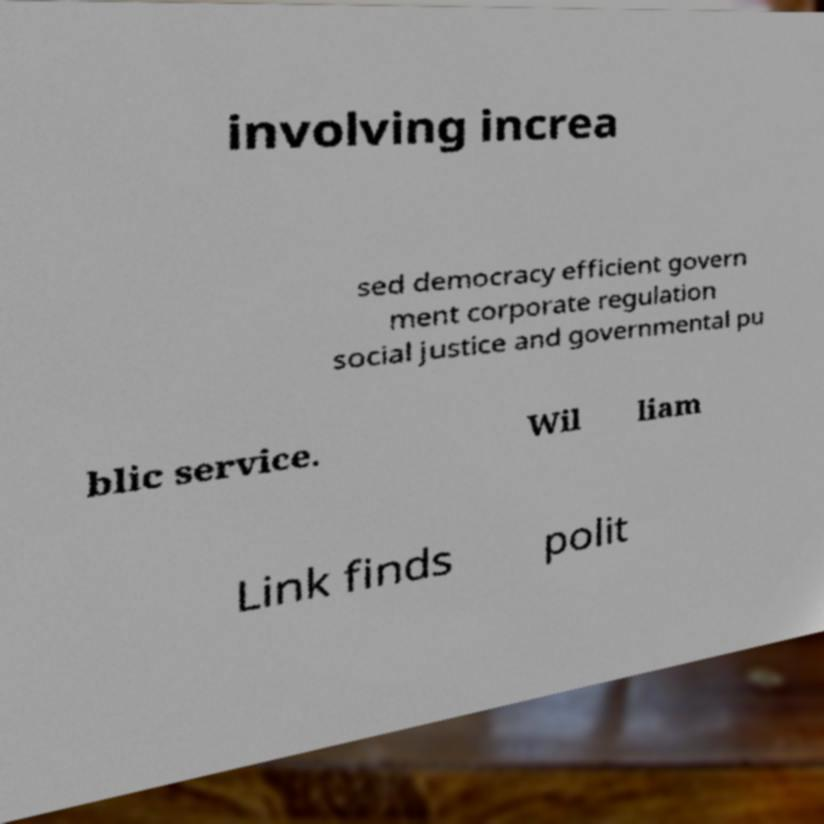For documentation purposes, I need the text within this image transcribed. Could you provide that? involving increa sed democracy efficient govern ment corporate regulation social justice and governmental pu blic service. Wil liam Link finds polit 